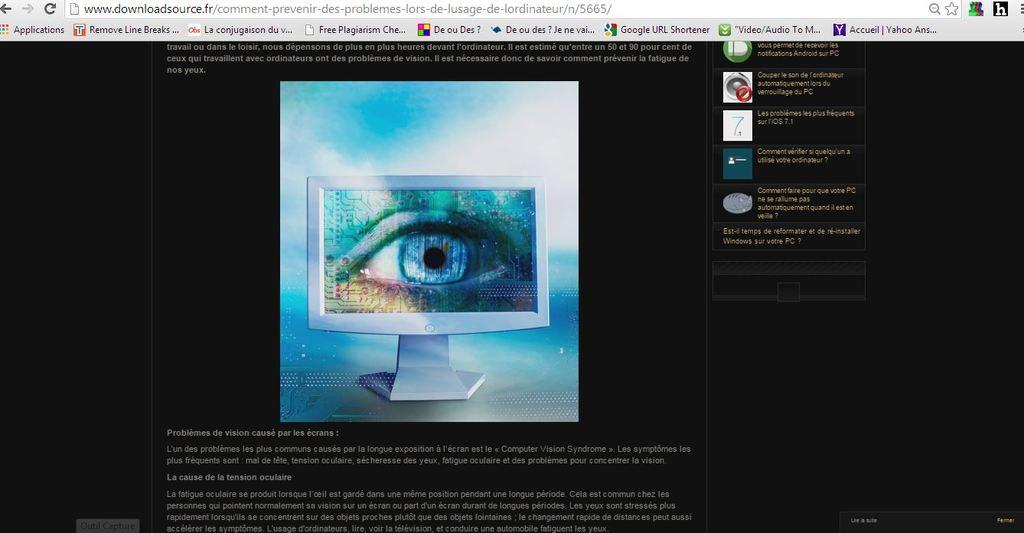<image>
Create a compact narrative representing the image presented. a computer screen with a tab open to a downloads page 